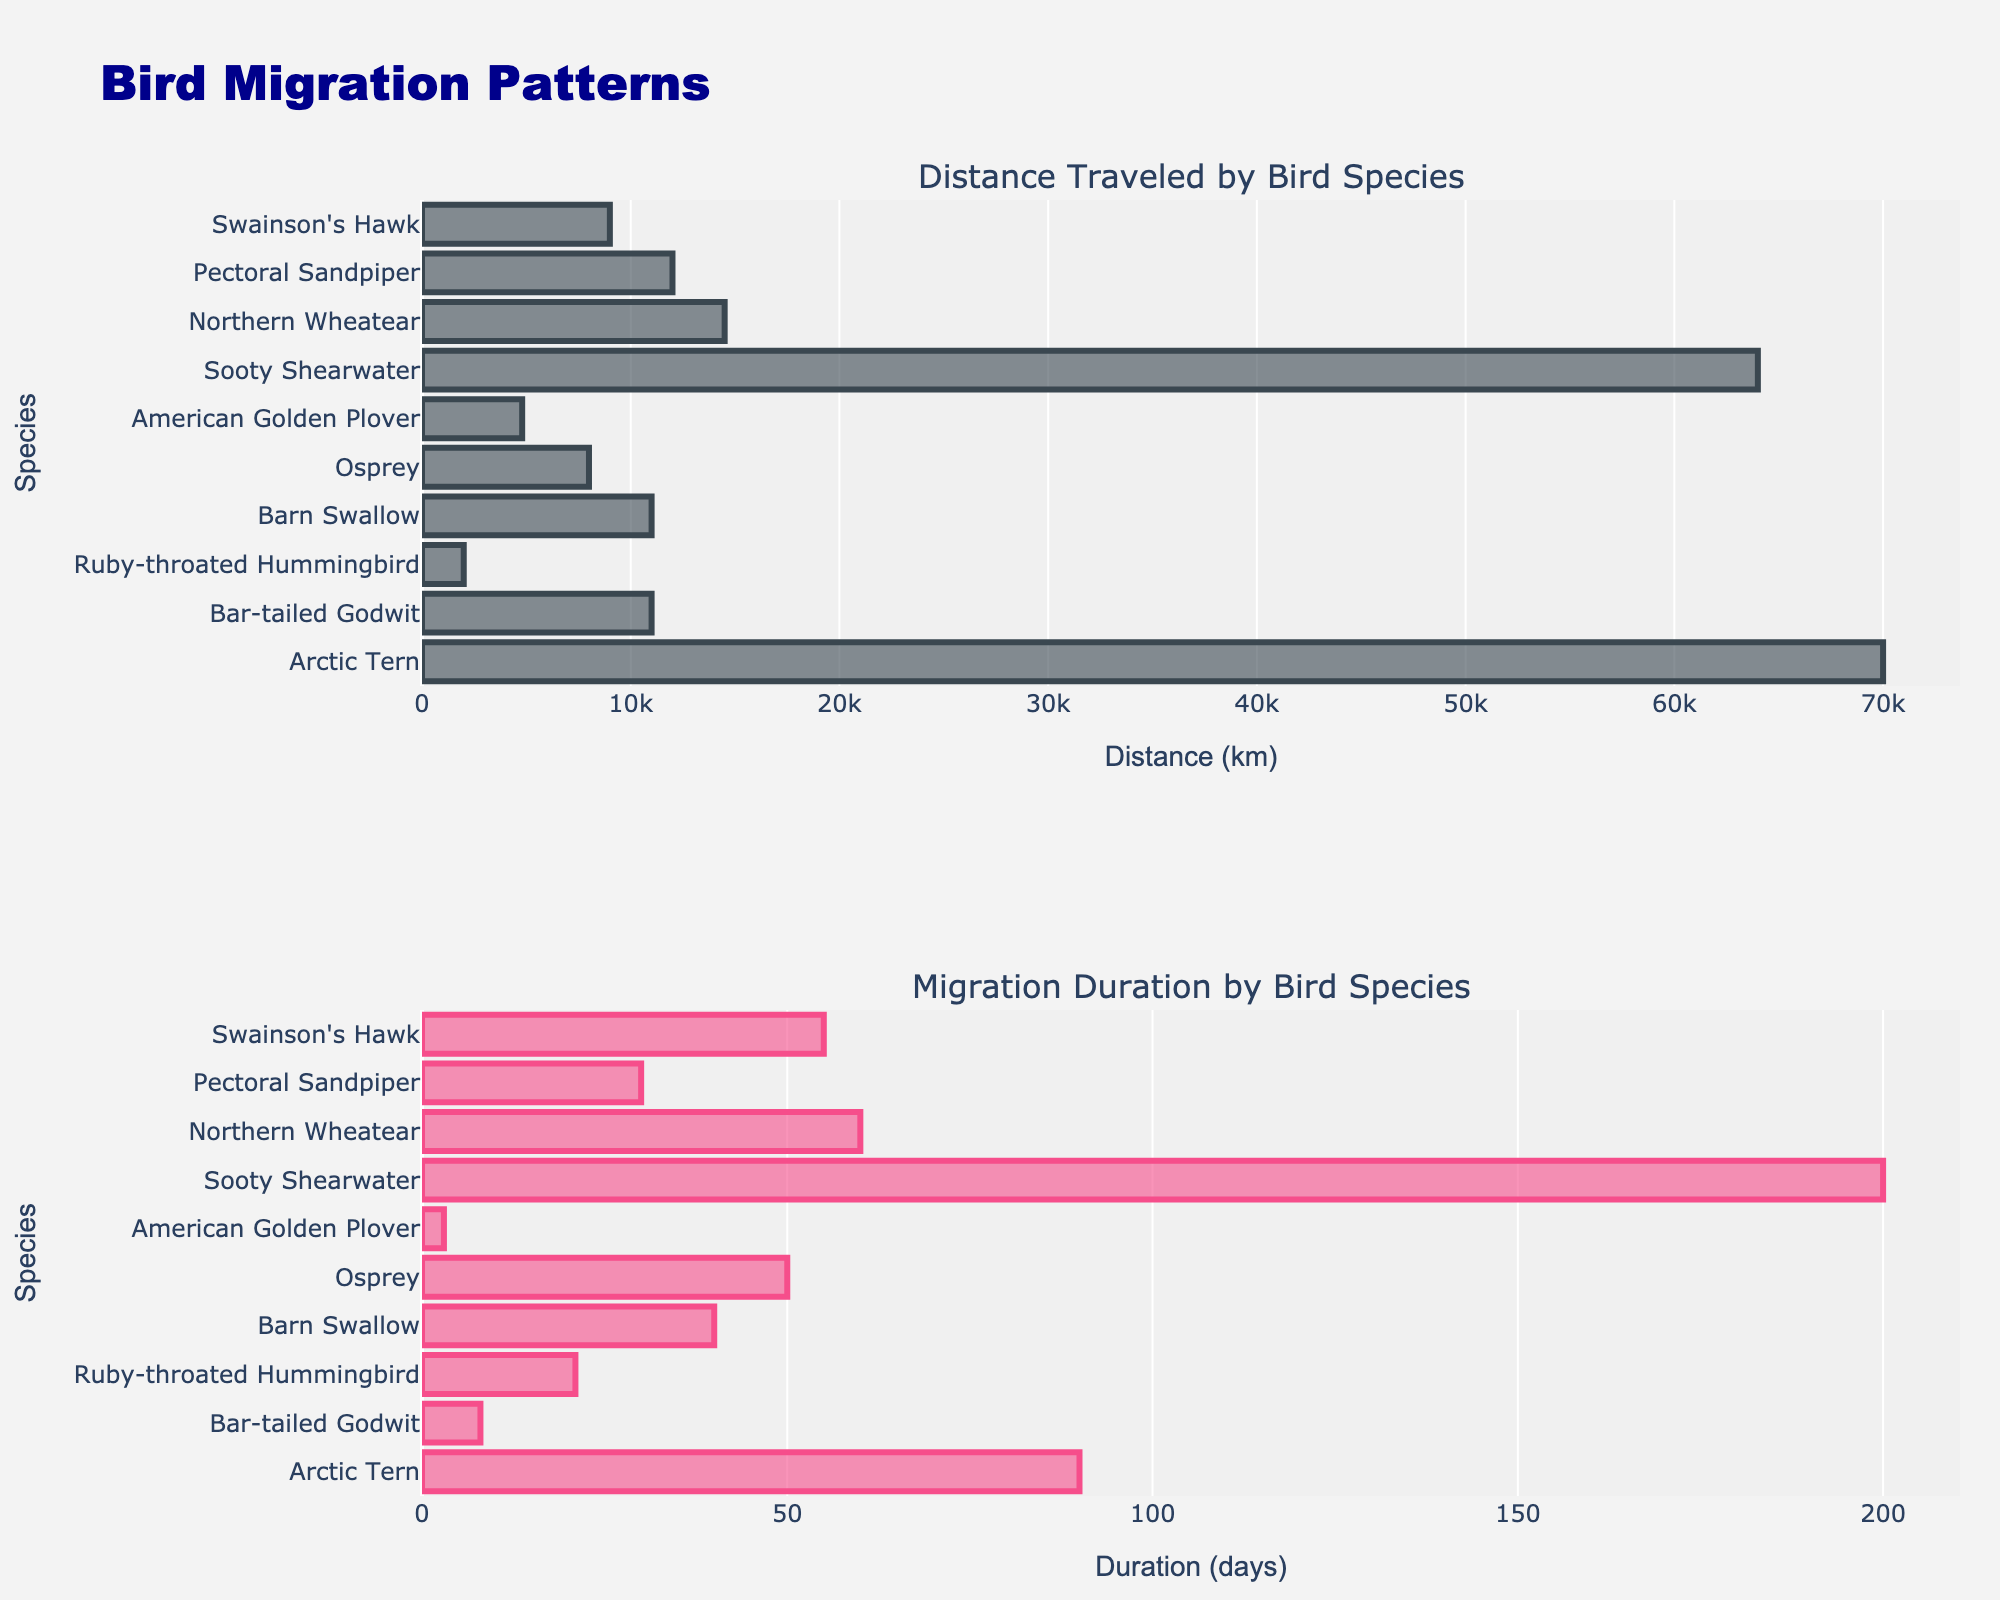How many providers are compared in the subplots? By looking at the figure, count the number of providers listed along the x-axes.
Answer: 8 Which provider has the highest average speed? Refer to the "Average Speed (Mbps)" subplot and find the provider with the tallest bar.
Answer: Starlink What is the cost per month for Telesat? Find Telesat in the "Cost per Month ($)" subplot and read the height of the bar.
Answer: $95 Which provider has the lowest reliability percentage? Refer to the "Reliability (%)" subplot and find the provider with the shortest bar.
Answer: Local DSL How much faster is Starlink compared to HughesNet? Subtract the average speed of HughesNet from that of Starlink using the "Average Speed (Mbps)" subplot: 100 - 25.
Answer: 75 Mbps Which provider offers a better speed-to-cost ratio, Viasat or OneWeb? Compare the positions in the "Speed vs. Cost" scatter plot for Viasat and OneWeb. Viasat has a lower speed (30 Mbps) and lower cost ($80) compared to OneWeb (80 Mbps, $100), determining the ratio.
Answer: OneWeb What is the combined cost per month for HughesNet and Local DSL? Add the cost per month values for HughesNet and Local DSL from the "Cost per Month ($)" subplot: 70 + 50.
Answer: $120 Which provider has the second-highest reliability percentage? In the "Reliability (%)" subplot, identify the second tallest bar.
Answer: OneWeb Is there a positive correlation between cost per month and average speed? Look at the "Speed vs. Cost" scatter plot. Generally, as cost increases, the speed also tends to increase, indicating a positive correlation.
Answer: Yes How much more reliable is OneWeb compared to Viasat? Subtract the reliability percentage of Viasat from that of OneWeb using the "Reliability (%)" subplot: 97% - 94%.
Answer: 3% 